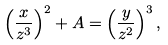Convert formula to latex. <formula><loc_0><loc_0><loc_500><loc_500>\left ( \frac { x } { z ^ { 3 } } \right ) ^ { 2 } + A = \left ( \frac { y } { z ^ { 2 } } \right ) ^ { 3 } ,</formula> 